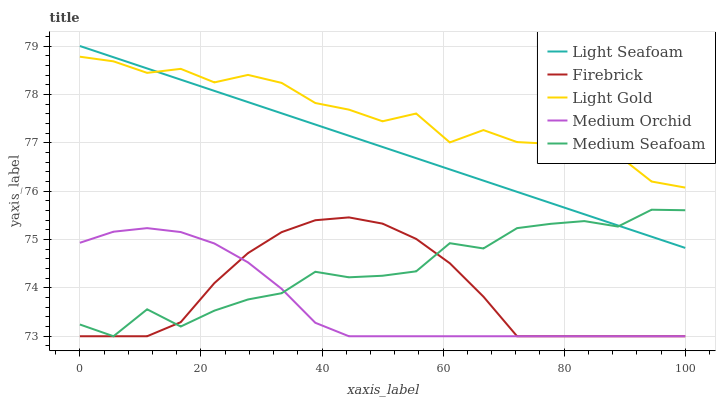Does Medium Orchid have the minimum area under the curve?
Answer yes or no. Yes. Does Light Gold have the maximum area under the curve?
Answer yes or no. Yes. Does Light Seafoam have the minimum area under the curve?
Answer yes or no. No. Does Light Seafoam have the maximum area under the curve?
Answer yes or no. No. Is Light Seafoam the smoothest?
Answer yes or no. Yes. Is Light Gold the roughest?
Answer yes or no. Yes. Is Light Gold the smoothest?
Answer yes or no. No. Is Light Seafoam the roughest?
Answer yes or no. No. Does Light Seafoam have the lowest value?
Answer yes or no. No. Does Light Gold have the highest value?
Answer yes or no. No. Is Firebrick less than Light Gold?
Answer yes or no. Yes. Is Light Seafoam greater than Medium Orchid?
Answer yes or no. Yes. Does Firebrick intersect Light Gold?
Answer yes or no. No. 